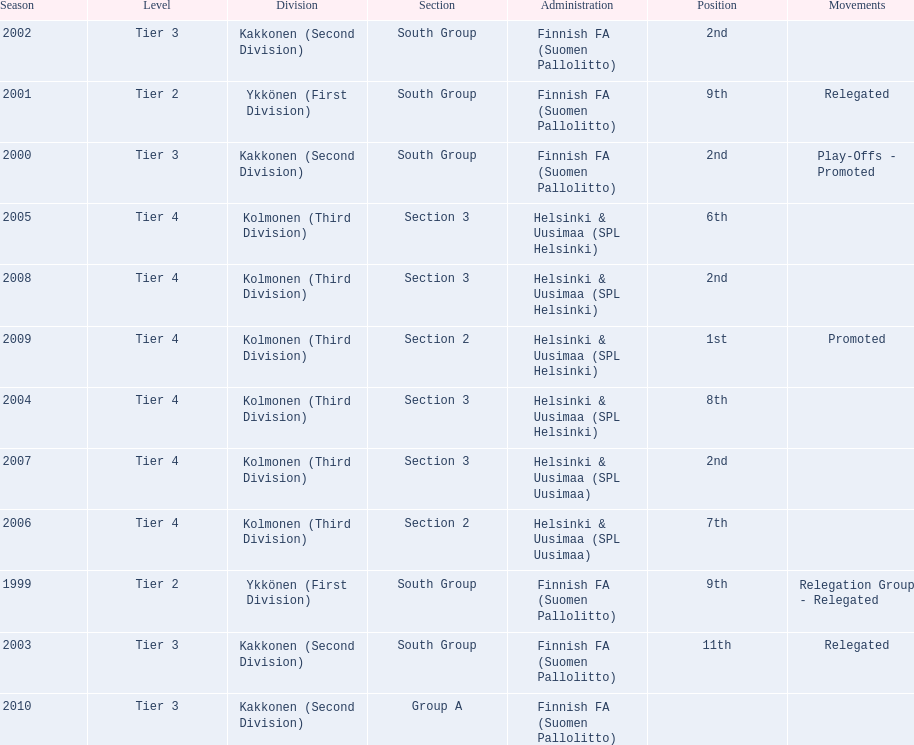How many 2nd positions were there? 4. Write the full table. {'header': ['Season', 'Level', 'Division', 'Section', 'Administration', 'Position', 'Movements'], 'rows': [['2002', 'Tier 3', 'Kakkonen (Second Division)', 'South Group', 'Finnish FA (Suomen Pallolitto)', '2nd', ''], ['2001', 'Tier 2', 'Ykkönen (First Division)', 'South Group', 'Finnish FA (Suomen Pallolitto)', '9th', 'Relegated'], ['2000', 'Tier 3', 'Kakkonen (Second Division)', 'South Group', 'Finnish FA (Suomen Pallolitto)', '2nd', 'Play-Offs - Promoted'], ['2005', 'Tier 4', 'Kolmonen (Third Division)', 'Section 3', 'Helsinki & Uusimaa (SPL Helsinki)', '6th', ''], ['2008', 'Tier 4', 'Kolmonen (Third Division)', 'Section 3', 'Helsinki & Uusimaa (SPL Helsinki)', '2nd', ''], ['2009', 'Tier 4', 'Kolmonen (Third Division)', 'Section 2', 'Helsinki & Uusimaa (SPL Helsinki)', '1st', 'Promoted'], ['2004', 'Tier 4', 'Kolmonen (Third Division)', 'Section 3', 'Helsinki & Uusimaa (SPL Helsinki)', '8th', ''], ['2007', 'Tier 4', 'Kolmonen (Third Division)', 'Section 3', 'Helsinki & Uusimaa (SPL Uusimaa)', '2nd', ''], ['2006', 'Tier 4', 'Kolmonen (Third Division)', 'Section 2', 'Helsinki & Uusimaa (SPL Uusimaa)', '7th', ''], ['1999', 'Tier 2', 'Ykkönen (First Division)', 'South Group', 'Finnish FA (Suomen Pallolitto)', '9th', 'Relegation Group - Relegated'], ['2003', 'Tier 3', 'Kakkonen (Second Division)', 'South Group', 'Finnish FA (Suomen Pallolitto)', '11th', 'Relegated'], ['2010', 'Tier 3', 'Kakkonen (Second Division)', 'Group A', 'Finnish FA (Suomen Pallolitto)', '', '']]} 